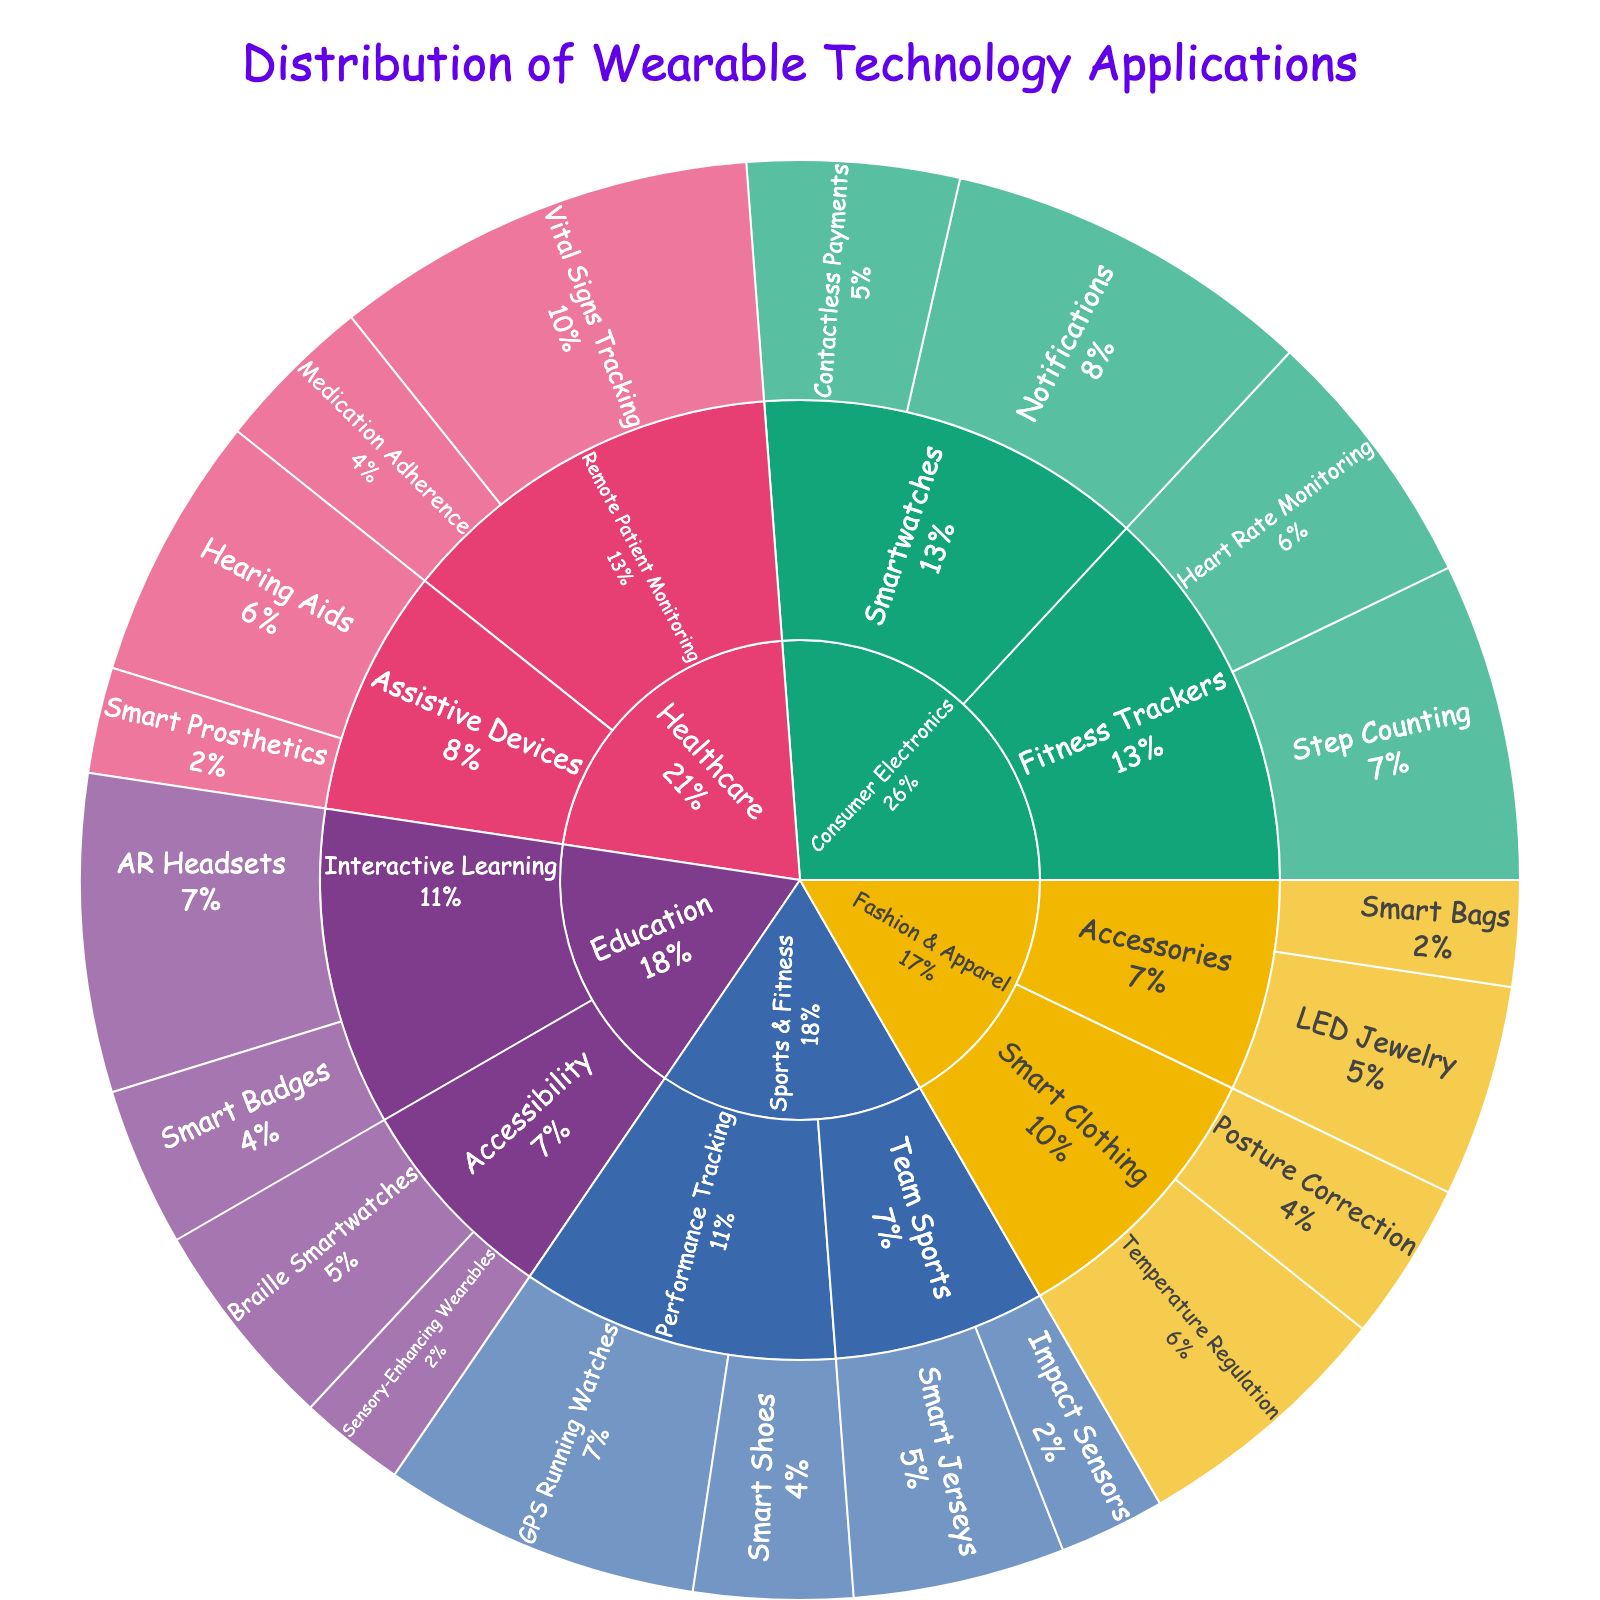What is the title of the figure? The title is usually located at the top of the figure. It summarizes the overall content of the chart.
Answer: Distribution of Wearable Technology Applications Which category has the highest value for 'Remote Patient Monitoring'? In the figure, locate the 'Healthcare' category, then find 'Remote Patient Monitoring' to see its subcategories. Compare the values for 'Vital Signs Tracking' and 'Medication Adherence'.
Answer: Vital Signs Tracking What is the total value for the 'Consumer Electronics' category? Add up all the values for the subcategories under 'Consumer Electronics' (Step Counting, Heart Rate Monitoring, Notifications, Contactless Payments). 30 + 25 + 35 + 20 = 110
Answer: 110 Which sub-category has the most diverse applications in 'Sports & Fitness'? In the figure, observe the sub-categories under 'Sports & Fitness'. Count the number of applications under each sub-category.
Answer: Performance Tracking How does the value of 'Temperature Regulation' in 'Fashion & Apparel' compare to 'GPS Running Watches' in 'Sports & Fitness'? Find 'Temperature Regulation' under 'Fashion & Apparel' and 'GPS Running Watches' under 'Sports & Fitness'. Compare their values. 25 vs. 30
Answer: GPS Running Watches has a higher value Which application has the smallest value under 'Education'? Navigate to the 'Education' category in the figure and look at values for 'AR Headsets', 'Smart Badges', 'Braille Smartwatches', and 'Sensory-Enhancing Wearables'.
Answer: Sensory-Enhancing Wearables What percentage of the total value does 'Posture Correction' represent in 'Fashion & Apparel'? Sum all the values under 'Fashion & Apparel' (25 + 15 + 20 + 10 = 70). Calculate the percentage: (15 / 70) * 100 ≈ 21.43%
Answer: 21.43% What is the combined value of all 'Team Sports' applications in 'Sports & Fitness'? Add up the values of 'Smart Jerseys' and 'Impact Sensors' under 'Team Sports'. 20 + 10 = 30
Answer: 30 Which category has the lowest total value overall? Sum the values within each category and compare them: Consumer Electronics (110), Healthcare (90), Sports & Fitness (75), Fashion & Apparel (70), Education (75).
Answer: Fashion & Apparel 